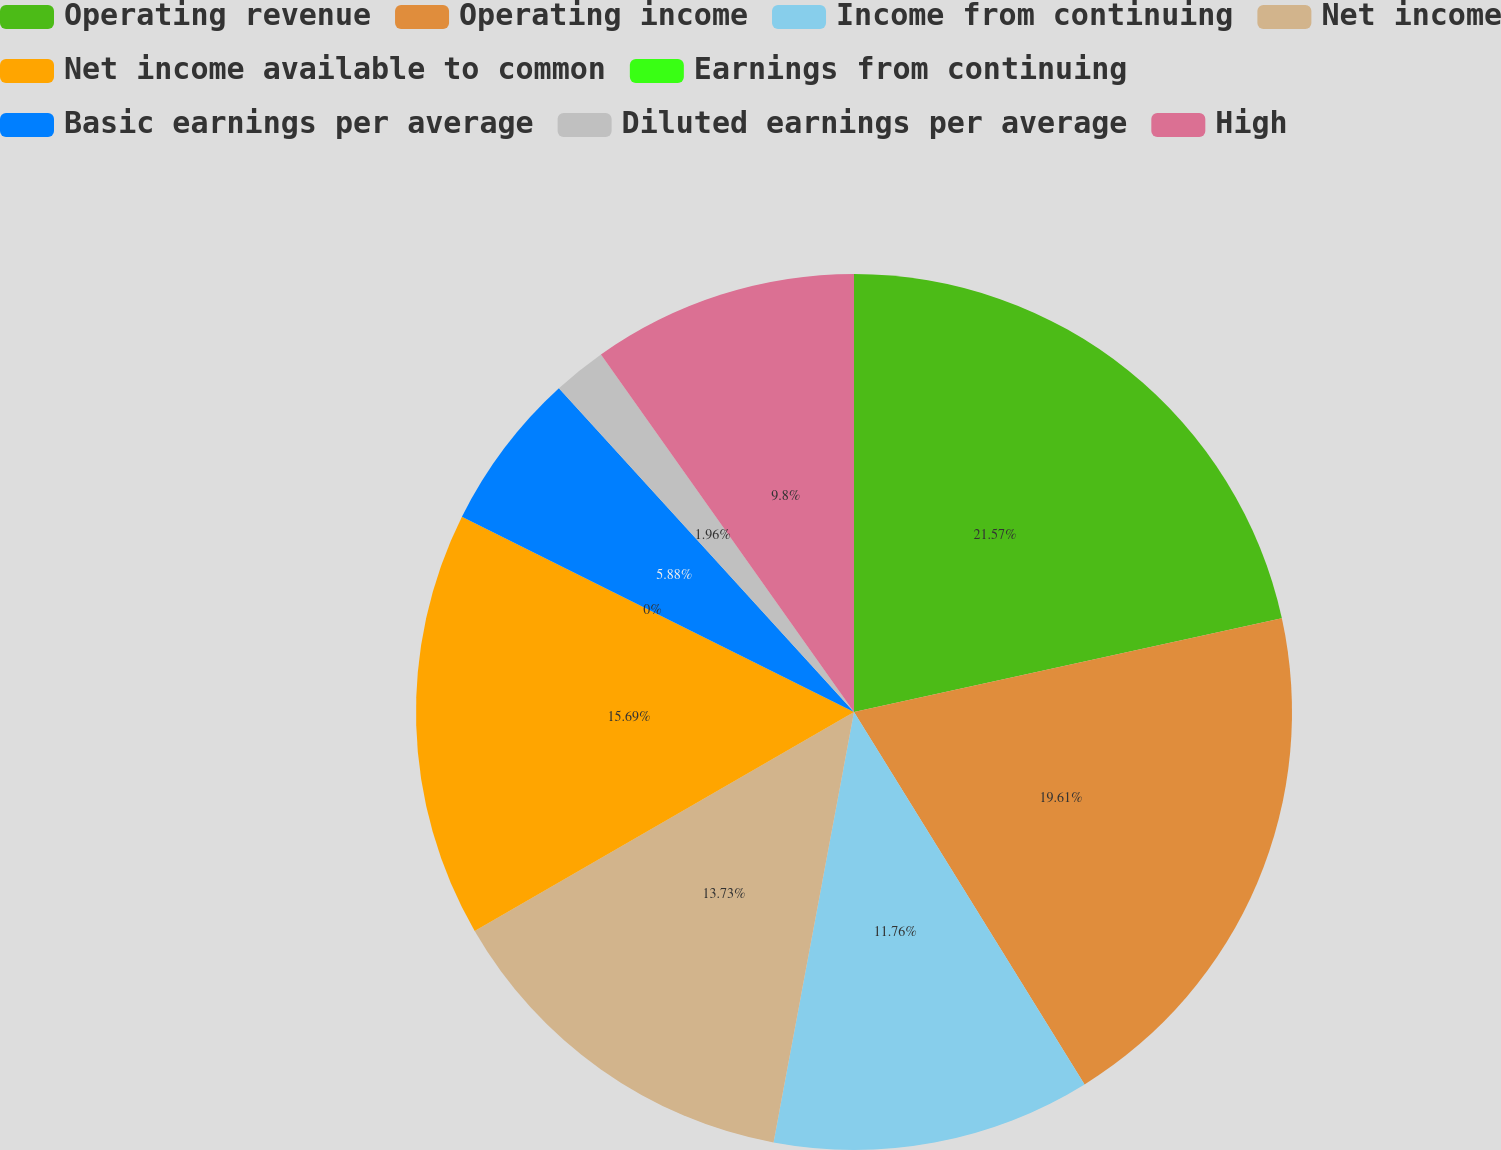Convert chart to OTSL. <chart><loc_0><loc_0><loc_500><loc_500><pie_chart><fcel>Operating revenue<fcel>Operating income<fcel>Income from continuing<fcel>Net income<fcel>Net income available to common<fcel>Earnings from continuing<fcel>Basic earnings per average<fcel>Diluted earnings per average<fcel>High<nl><fcel>21.56%<fcel>19.6%<fcel>11.76%<fcel>13.72%<fcel>15.68%<fcel>0.0%<fcel>5.88%<fcel>1.96%<fcel>9.8%<nl></chart> 